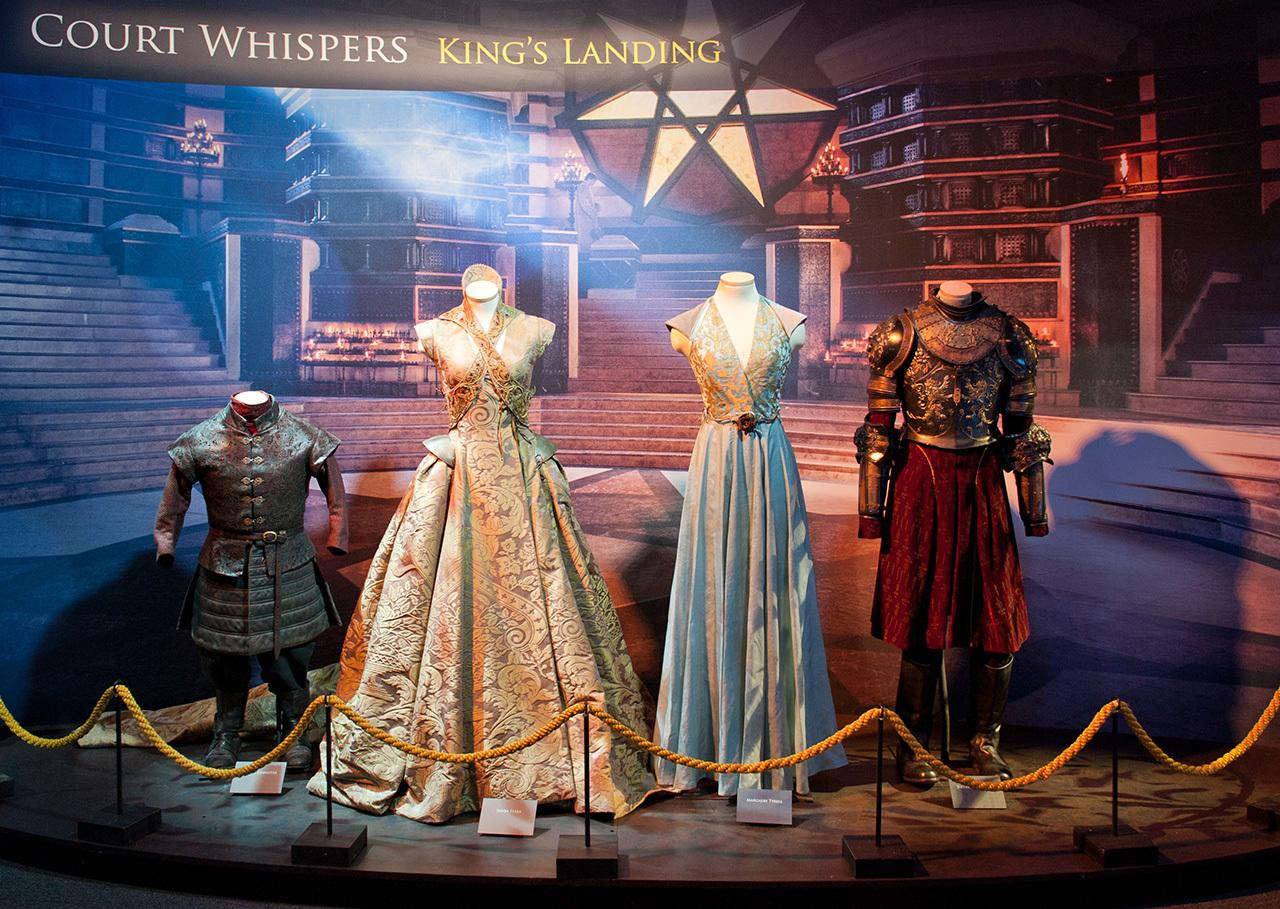How do these costumes reflect the historical or fictional settings they are intended to represent? These costumes are designed to evoke a sense of time and place that blurs the lines between historical accuracy and imaginative fiction. The ornate patterns and bold silhouettes reflect the regal and authoritarian nature typical of medieval royalty, yet they are adapted with a creative license that likely draws inspiration from various European medieval eras. The integration of fantasy elements into the costumes’ design helps in crafting a visually captivating narrative that resonates with fans of historical dramas and epic fantasy. Can you give examples of specific historical eras or styles these costumes resemble? Certainly! The armored costume on the right is reminiscent of 15th-century European plate armor, with intricate detailing that suggests status and valor. The middle costume, with its elaborate gown featuring gold thread and floral embroidery, echoes the Renaissance fashion known for its opulence. The softer, flowing lines of the dress on the left might draw inspiration from the lighter, airier court dresses of the Baroque period, which emphasized breathability and movement alongside luxury. 